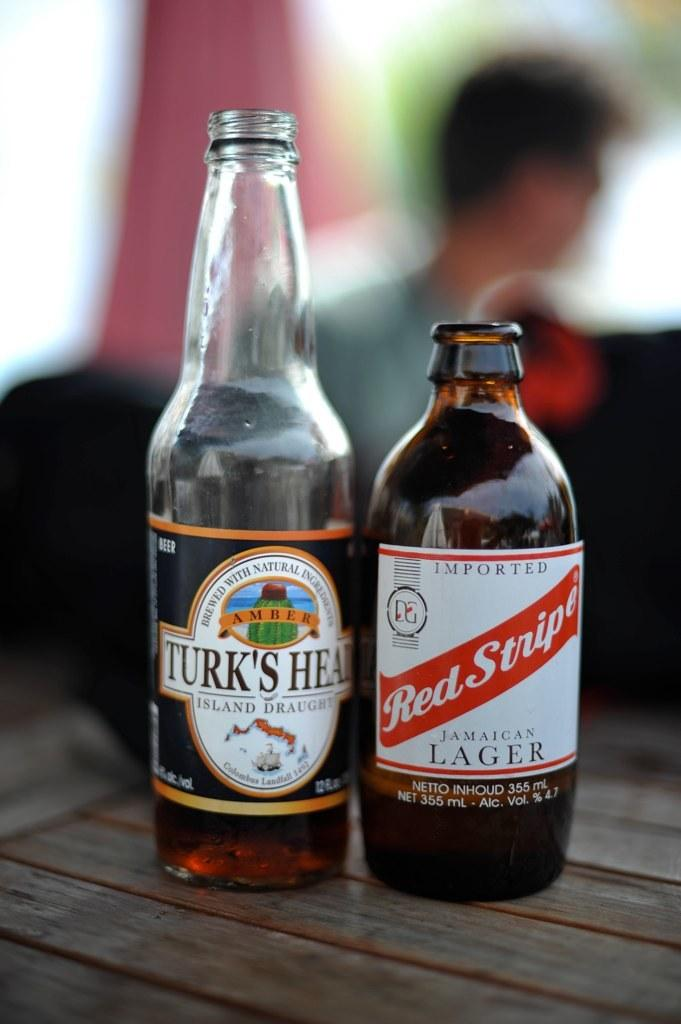Provide a one-sentence caption for the provided image. A bottle of Turk's Head and Red Stripes lager beer on a table. 